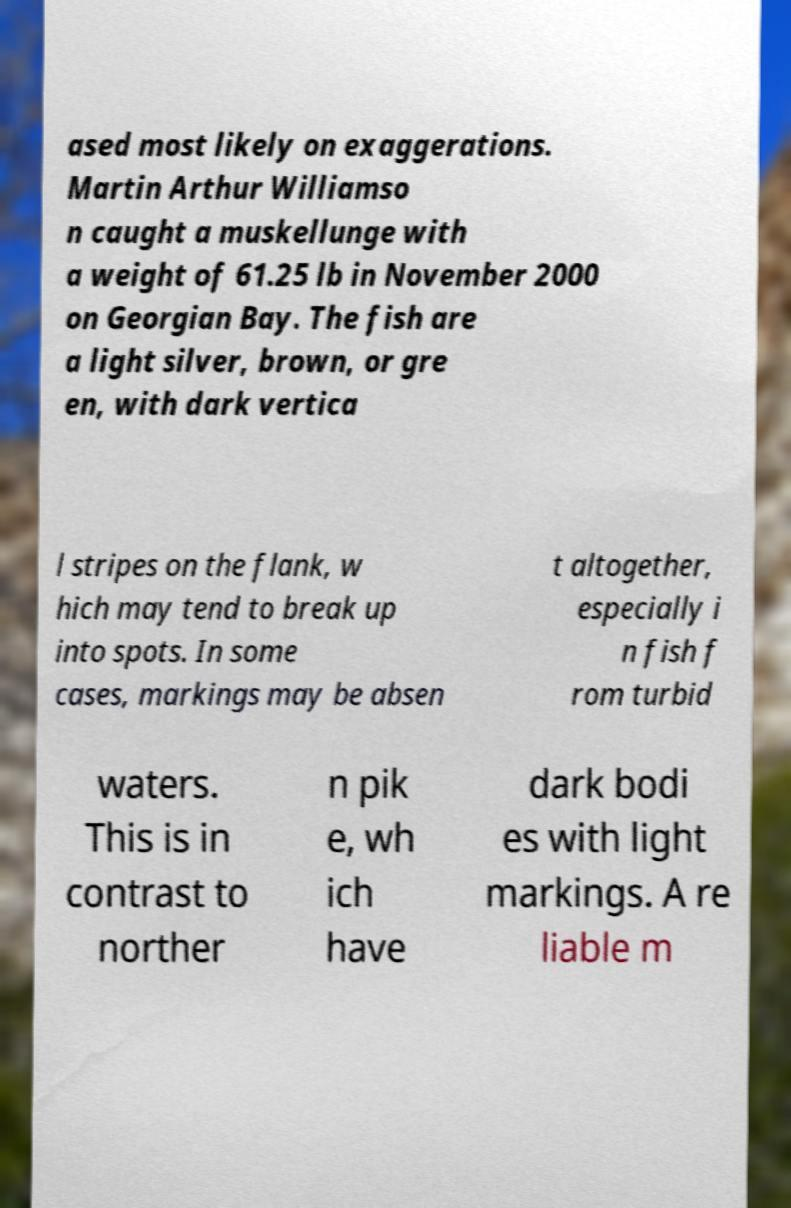Can you accurately transcribe the text from the provided image for me? ased most likely on exaggerations. Martin Arthur Williamso n caught a muskellunge with a weight of 61.25 lb in November 2000 on Georgian Bay. The fish are a light silver, brown, or gre en, with dark vertica l stripes on the flank, w hich may tend to break up into spots. In some cases, markings may be absen t altogether, especially i n fish f rom turbid waters. This is in contrast to norther n pik e, wh ich have dark bodi es with light markings. A re liable m 